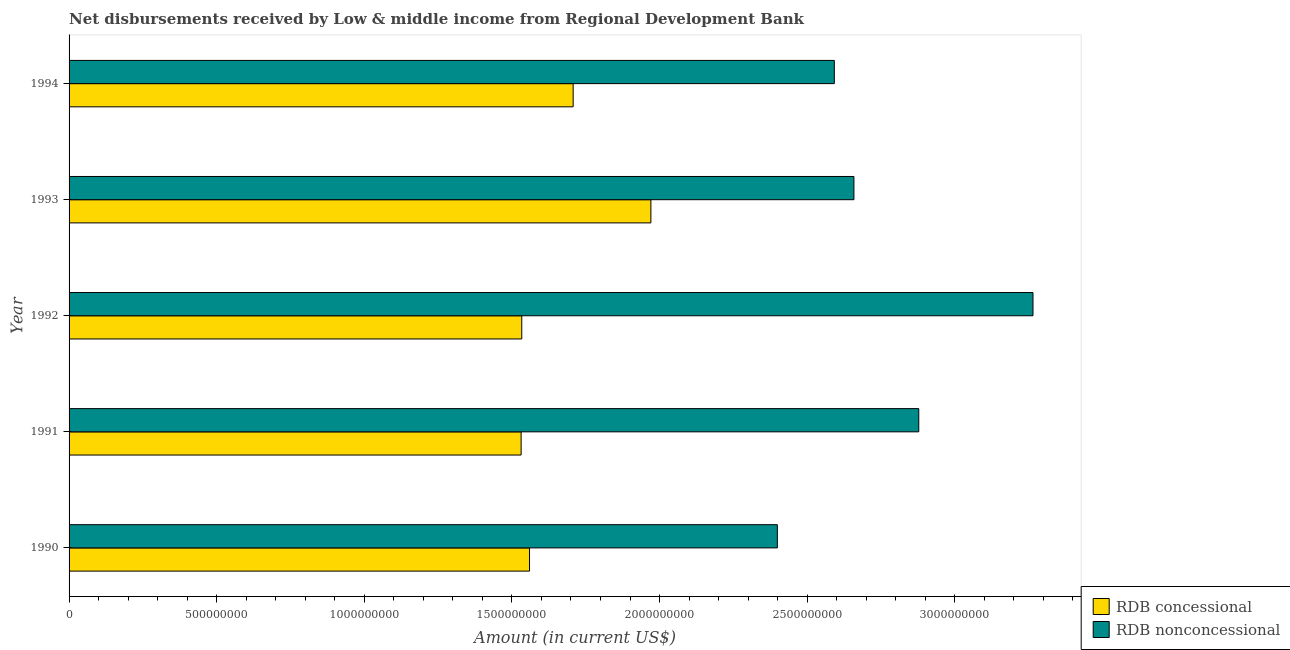Are the number of bars per tick equal to the number of legend labels?
Your answer should be very brief. Yes. How many bars are there on the 1st tick from the bottom?
Your answer should be very brief. 2. What is the label of the 2nd group of bars from the top?
Offer a terse response. 1993. In how many cases, is the number of bars for a given year not equal to the number of legend labels?
Offer a very short reply. 0. What is the net concessional disbursements from rdb in 1992?
Provide a short and direct response. 1.53e+09. Across all years, what is the maximum net non concessional disbursements from rdb?
Give a very brief answer. 3.27e+09. Across all years, what is the minimum net concessional disbursements from rdb?
Make the answer very short. 1.53e+09. What is the total net concessional disbursements from rdb in the graph?
Your answer should be compact. 8.30e+09. What is the difference between the net concessional disbursements from rdb in 1990 and that in 1994?
Provide a succinct answer. -1.48e+08. What is the difference between the net non concessional disbursements from rdb in 1992 and the net concessional disbursements from rdb in 1993?
Provide a succinct answer. 1.29e+09. What is the average net concessional disbursements from rdb per year?
Your answer should be compact. 1.66e+09. In the year 1991, what is the difference between the net non concessional disbursements from rdb and net concessional disbursements from rdb?
Your answer should be very brief. 1.35e+09. What is the ratio of the net non concessional disbursements from rdb in 1991 to that in 1992?
Your answer should be very brief. 0.88. What is the difference between the highest and the second highest net concessional disbursements from rdb?
Provide a succinct answer. 2.63e+08. What is the difference between the highest and the lowest net non concessional disbursements from rdb?
Make the answer very short. 8.66e+08. What does the 1st bar from the top in 1993 represents?
Your response must be concise. RDB nonconcessional. What does the 1st bar from the bottom in 1990 represents?
Make the answer very short. RDB concessional. Are all the bars in the graph horizontal?
Give a very brief answer. Yes. Does the graph contain any zero values?
Make the answer very short. No. Does the graph contain grids?
Provide a succinct answer. No. What is the title of the graph?
Ensure brevity in your answer.  Net disbursements received by Low & middle income from Regional Development Bank. What is the label or title of the X-axis?
Ensure brevity in your answer.  Amount (in current US$). What is the label or title of the Y-axis?
Give a very brief answer. Year. What is the Amount (in current US$) in RDB concessional in 1990?
Keep it short and to the point. 1.56e+09. What is the Amount (in current US$) in RDB nonconcessional in 1990?
Give a very brief answer. 2.40e+09. What is the Amount (in current US$) of RDB concessional in 1991?
Offer a terse response. 1.53e+09. What is the Amount (in current US$) in RDB nonconcessional in 1991?
Keep it short and to the point. 2.88e+09. What is the Amount (in current US$) of RDB concessional in 1992?
Offer a very short reply. 1.53e+09. What is the Amount (in current US$) of RDB nonconcessional in 1992?
Your answer should be very brief. 3.27e+09. What is the Amount (in current US$) in RDB concessional in 1993?
Your response must be concise. 1.97e+09. What is the Amount (in current US$) in RDB nonconcessional in 1993?
Provide a short and direct response. 2.66e+09. What is the Amount (in current US$) of RDB concessional in 1994?
Provide a succinct answer. 1.71e+09. What is the Amount (in current US$) of RDB nonconcessional in 1994?
Keep it short and to the point. 2.59e+09. Across all years, what is the maximum Amount (in current US$) in RDB concessional?
Give a very brief answer. 1.97e+09. Across all years, what is the maximum Amount (in current US$) of RDB nonconcessional?
Ensure brevity in your answer.  3.27e+09. Across all years, what is the minimum Amount (in current US$) of RDB concessional?
Give a very brief answer. 1.53e+09. Across all years, what is the minimum Amount (in current US$) of RDB nonconcessional?
Provide a short and direct response. 2.40e+09. What is the total Amount (in current US$) in RDB concessional in the graph?
Your response must be concise. 8.30e+09. What is the total Amount (in current US$) in RDB nonconcessional in the graph?
Give a very brief answer. 1.38e+1. What is the difference between the Amount (in current US$) in RDB concessional in 1990 and that in 1991?
Give a very brief answer. 2.84e+07. What is the difference between the Amount (in current US$) of RDB nonconcessional in 1990 and that in 1991?
Give a very brief answer. -4.79e+08. What is the difference between the Amount (in current US$) in RDB concessional in 1990 and that in 1992?
Make the answer very short. 2.62e+07. What is the difference between the Amount (in current US$) of RDB nonconcessional in 1990 and that in 1992?
Ensure brevity in your answer.  -8.66e+08. What is the difference between the Amount (in current US$) in RDB concessional in 1990 and that in 1993?
Give a very brief answer. -4.11e+08. What is the difference between the Amount (in current US$) of RDB nonconcessional in 1990 and that in 1993?
Your answer should be compact. -2.59e+08. What is the difference between the Amount (in current US$) of RDB concessional in 1990 and that in 1994?
Make the answer very short. -1.48e+08. What is the difference between the Amount (in current US$) of RDB nonconcessional in 1990 and that in 1994?
Your answer should be compact. -1.93e+08. What is the difference between the Amount (in current US$) in RDB concessional in 1991 and that in 1992?
Provide a short and direct response. -2.18e+06. What is the difference between the Amount (in current US$) in RDB nonconcessional in 1991 and that in 1992?
Offer a very short reply. -3.87e+08. What is the difference between the Amount (in current US$) in RDB concessional in 1991 and that in 1993?
Offer a terse response. -4.40e+08. What is the difference between the Amount (in current US$) of RDB nonconcessional in 1991 and that in 1993?
Offer a terse response. 2.20e+08. What is the difference between the Amount (in current US$) of RDB concessional in 1991 and that in 1994?
Provide a succinct answer. -1.76e+08. What is the difference between the Amount (in current US$) in RDB nonconcessional in 1991 and that in 1994?
Your answer should be very brief. 2.86e+08. What is the difference between the Amount (in current US$) in RDB concessional in 1992 and that in 1993?
Ensure brevity in your answer.  -4.37e+08. What is the difference between the Amount (in current US$) of RDB nonconcessional in 1992 and that in 1993?
Your response must be concise. 6.07e+08. What is the difference between the Amount (in current US$) of RDB concessional in 1992 and that in 1994?
Keep it short and to the point. -1.74e+08. What is the difference between the Amount (in current US$) in RDB nonconcessional in 1992 and that in 1994?
Your answer should be compact. 6.73e+08. What is the difference between the Amount (in current US$) of RDB concessional in 1993 and that in 1994?
Offer a terse response. 2.63e+08. What is the difference between the Amount (in current US$) of RDB nonconcessional in 1993 and that in 1994?
Your answer should be very brief. 6.64e+07. What is the difference between the Amount (in current US$) in RDB concessional in 1990 and the Amount (in current US$) in RDB nonconcessional in 1991?
Give a very brief answer. -1.32e+09. What is the difference between the Amount (in current US$) in RDB concessional in 1990 and the Amount (in current US$) in RDB nonconcessional in 1992?
Offer a terse response. -1.71e+09. What is the difference between the Amount (in current US$) in RDB concessional in 1990 and the Amount (in current US$) in RDB nonconcessional in 1993?
Offer a terse response. -1.10e+09. What is the difference between the Amount (in current US$) in RDB concessional in 1990 and the Amount (in current US$) in RDB nonconcessional in 1994?
Your answer should be compact. -1.03e+09. What is the difference between the Amount (in current US$) in RDB concessional in 1991 and the Amount (in current US$) in RDB nonconcessional in 1992?
Give a very brief answer. -1.73e+09. What is the difference between the Amount (in current US$) in RDB concessional in 1991 and the Amount (in current US$) in RDB nonconcessional in 1993?
Provide a succinct answer. -1.13e+09. What is the difference between the Amount (in current US$) in RDB concessional in 1991 and the Amount (in current US$) in RDB nonconcessional in 1994?
Ensure brevity in your answer.  -1.06e+09. What is the difference between the Amount (in current US$) of RDB concessional in 1992 and the Amount (in current US$) of RDB nonconcessional in 1993?
Your response must be concise. -1.13e+09. What is the difference between the Amount (in current US$) in RDB concessional in 1992 and the Amount (in current US$) in RDB nonconcessional in 1994?
Ensure brevity in your answer.  -1.06e+09. What is the difference between the Amount (in current US$) of RDB concessional in 1993 and the Amount (in current US$) of RDB nonconcessional in 1994?
Give a very brief answer. -6.21e+08. What is the average Amount (in current US$) of RDB concessional per year?
Provide a succinct answer. 1.66e+09. What is the average Amount (in current US$) of RDB nonconcessional per year?
Make the answer very short. 2.76e+09. In the year 1990, what is the difference between the Amount (in current US$) of RDB concessional and Amount (in current US$) of RDB nonconcessional?
Your response must be concise. -8.39e+08. In the year 1991, what is the difference between the Amount (in current US$) in RDB concessional and Amount (in current US$) in RDB nonconcessional?
Provide a short and direct response. -1.35e+09. In the year 1992, what is the difference between the Amount (in current US$) in RDB concessional and Amount (in current US$) in RDB nonconcessional?
Your answer should be very brief. -1.73e+09. In the year 1993, what is the difference between the Amount (in current US$) of RDB concessional and Amount (in current US$) of RDB nonconcessional?
Your answer should be compact. -6.88e+08. In the year 1994, what is the difference between the Amount (in current US$) of RDB concessional and Amount (in current US$) of RDB nonconcessional?
Ensure brevity in your answer.  -8.85e+08. What is the ratio of the Amount (in current US$) in RDB concessional in 1990 to that in 1991?
Your answer should be compact. 1.02. What is the ratio of the Amount (in current US$) of RDB nonconcessional in 1990 to that in 1991?
Keep it short and to the point. 0.83. What is the ratio of the Amount (in current US$) in RDB concessional in 1990 to that in 1992?
Offer a very short reply. 1.02. What is the ratio of the Amount (in current US$) of RDB nonconcessional in 1990 to that in 1992?
Give a very brief answer. 0.73. What is the ratio of the Amount (in current US$) of RDB concessional in 1990 to that in 1993?
Make the answer very short. 0.79. What is the ratio of the Amount (in current US$) in RDB nonconcessional in 1990 to that in 1993?
Make the answer very short. 0.9. What is the ratio of the Amount (in current US$) of RDB concessional in 1990 to that in 1994?
Give a very brief answer. 0.91. What is the ratio of the Amount (in current US$) of RDB nonconcessional in 1990 to that in 1994?
Provide a succinct answer. 0.93. What is the ratio of the Amount (in current US$) of RDB nonconcessional in 1991 to that in 1992?
Your answer should be very brief. 0.88. What is the ratio of the Amount (in current US$) of RDB concessional in 1991 to that in 1993?
Provide a succinct answer. 0.78. What is the ratio of the Amount (in current US$) of RDB nonconcessional in 1991 to that in 1993?
Provide a short and direct response. 1.08. What is the ratio of the Amount (in current US$) in RDB concessional in 1991 to that in 1994?
Offer a terse response. 0.9. What is the ratio of the Amount (in current US$) in RDB nonconcessional in 1991 to that in 1994?
Ensure brevity in your answer.  1.11. What is the ratio of the Amount (in current US$) of RDB concessional in 1992 to that in 1993?
Your answer should be very brief. 0.78. What is the ratio of the Amount (in current US$) of RDB nonconcessional in 1992 to that in 1993?
Provide a short and direct response. 1.23. What is the ratio of the Amount (in current US$) in RDB concessional in 1992 to that in 1994?
Give a very brief answer. 0.9. What is the ratio of the Amount (in current US$) of RDB nonconcessional in 1992 to that in 1994?
Offer a very short reply. 1.26. What is the ratio of the Amount (in current US$) in RDB concessional in 1993 to that in 1994?
Provide a succinct answer. 1.15. What is the ratio of the Amount (in current US$) of RDB nonconcessional in 1993 to that in 1994?
Ensure brevity in your answer.  1.03. What is the difference between the highest and the second highest Amount (in current US$) of RDB concessional?
Ensure brevity in your answer.  2.63e+08. What is the difference between the highest and the second highest Amount (in current US$) of RDB nonconcessional?
Your answer should be very brief. 3.87e+08. What is the difference between the highest and the lowest Amount (in current US$) in RDB concessional?
Ensure brevity in your answer.  4.40e+08. What is the difference between the highest and the lowest Amount (in current US$) in RDB nonconcessional?
Your answer should be compact. 8.66e+08. 